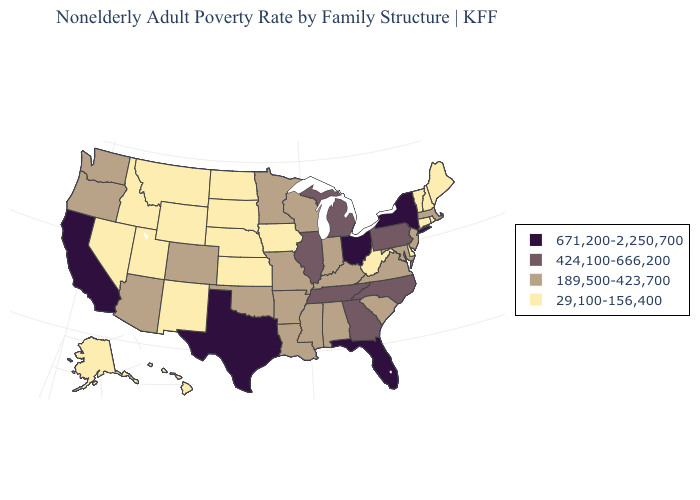Does Hawaii have the lowest value in the West?
Keep it brief. Yes. Which states have the lowest value in the USA?
Quick response, please. Alaska, Connecticut, Delaware, Hawaii, Idaho, Iowa, Kansas, Maine, Montana, Nebraska, Nevada, New Hampshire, New Mexico, North Dakota, Rhode Island, South Dakota, Utah, Vermont, West Virginia, Wyoming. Name the states that have a value in the range 424,100-666,200?
Short answer required. Georgia, Illinois, Michigan, North Carolina, Pennsylvania, Tennessee. Name the states that have a value in the range 424,100-666,200?
Concise answer only. Georgia, Illinois, Michigan, North Carolina, Pennsylvania, Tennessee. Does Texas have the same value as Delaware?
Short answer required. No. What is the value of Louisiana?
Quick response, please. 189,500-423,700. What is the value of Ohio?
Answer briefly. 671,200-2,250,700. Name the states that have a value in the range 424,100-666,200?
Keep it brief. Georgia, Illinois, Michigan, North Carolina, Pennsylvania, Tennessee. Name the states that have a value in the range 424,100-666,200?
Write a very short answer. Georgia, Illinois, Michigan, North Carolina, Pennsylvania, Tennessee. Does the first symbol in the legend represent the smallest category?
Keep it brief. No. What is the lowest value in the South?
Short answer required. 29,100-156,400. Among the states that border Washington , which have the highest value?
Keep it brief. Oregon. How many symbols are there in the legend?
Answer briefly. 4. Name the states that have a value in the range 29,100-156,400?
Quick response, please. Alaska, Connecticut, Delaware, Hawaii, Idaho, Iowa, Kansas, Maine, Montana, Nebraska, Nevada, New Hampshire, New Mexico, North Dakota, Rhode Island, South Dakota, Utah, Vermont, West Virginia, Wyoming. 